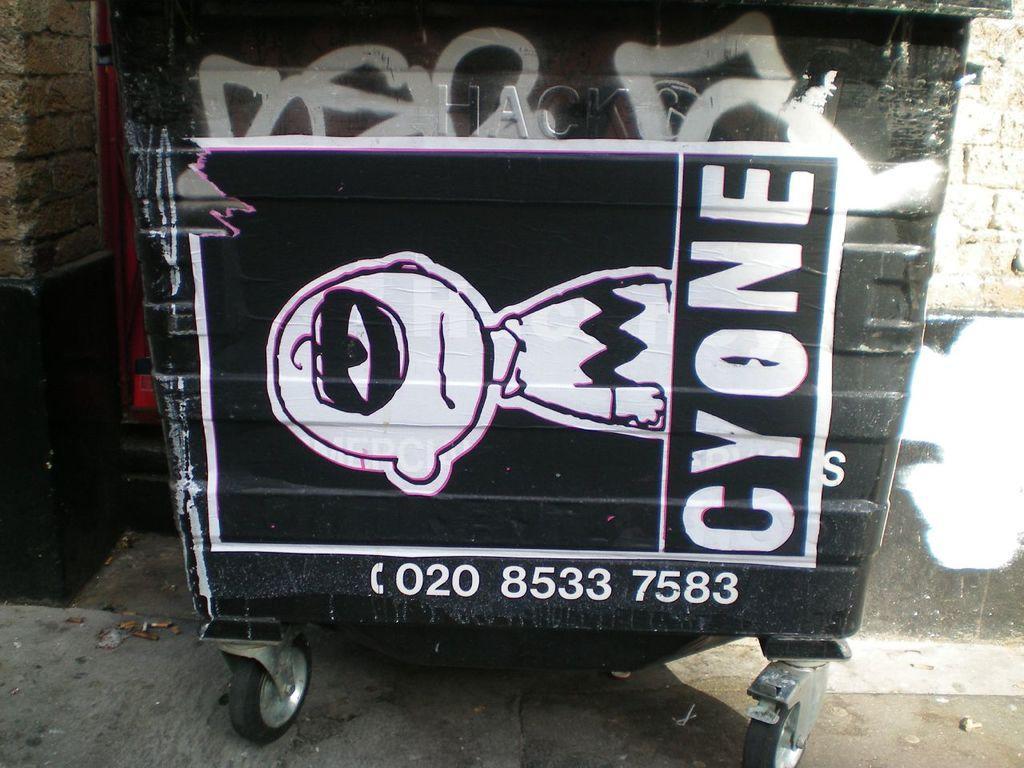Can you describe this image briefly? In this image in the front there is a trolley with some text and numbers written on it and there is a cartoon image on the trolley. On the left side there is a wall and on the right side there is a wall. 